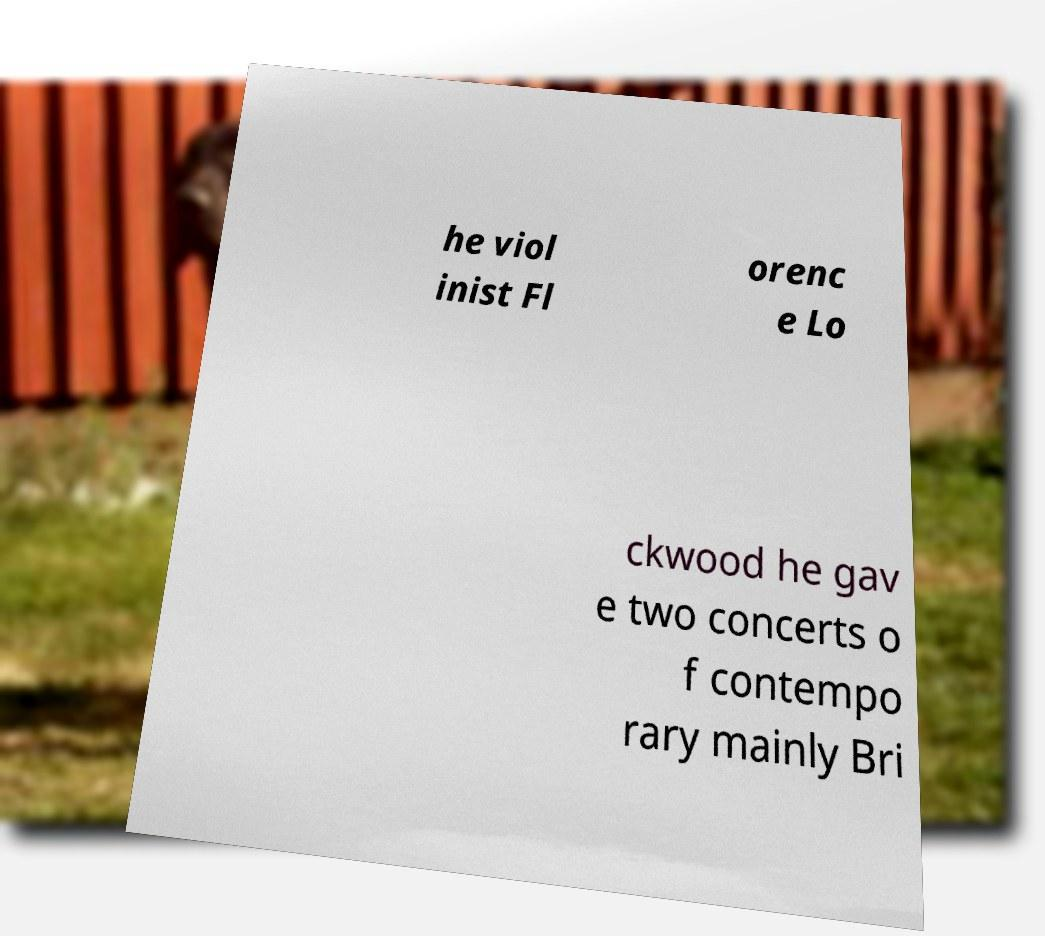Could you assist in decoding the text presented in this image and type it out clearly? he viol inist Fl orenc e Lo ckwood he gav e two concerts o f contempo rary mainly Bri 